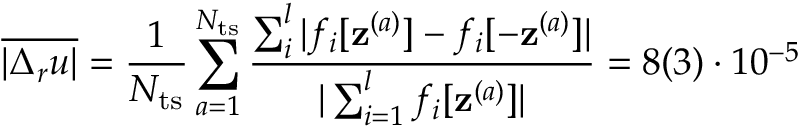<formula> <loc_0><loc_0><loc_500><loc_500>\overline { { | \Delta _ { r } u | } } = \frac { 1 } { N _ { t s } } \sum _ { a = 1 } ^ { N _ { t s } } \frac { \sum _ { i } ^ { l } | { f } _ { i } [ z ^ { ( a ) } ] - { f } _ { i } [ - z ^ { ( a ) } ] | } { | \sum _ { i = 1 } ^ { l } { f } _ { i } [ z ^ { ( a ) } ] | } = 8 ( 3 ) \cdot 1 0 ^ { - 5 }</formula> 